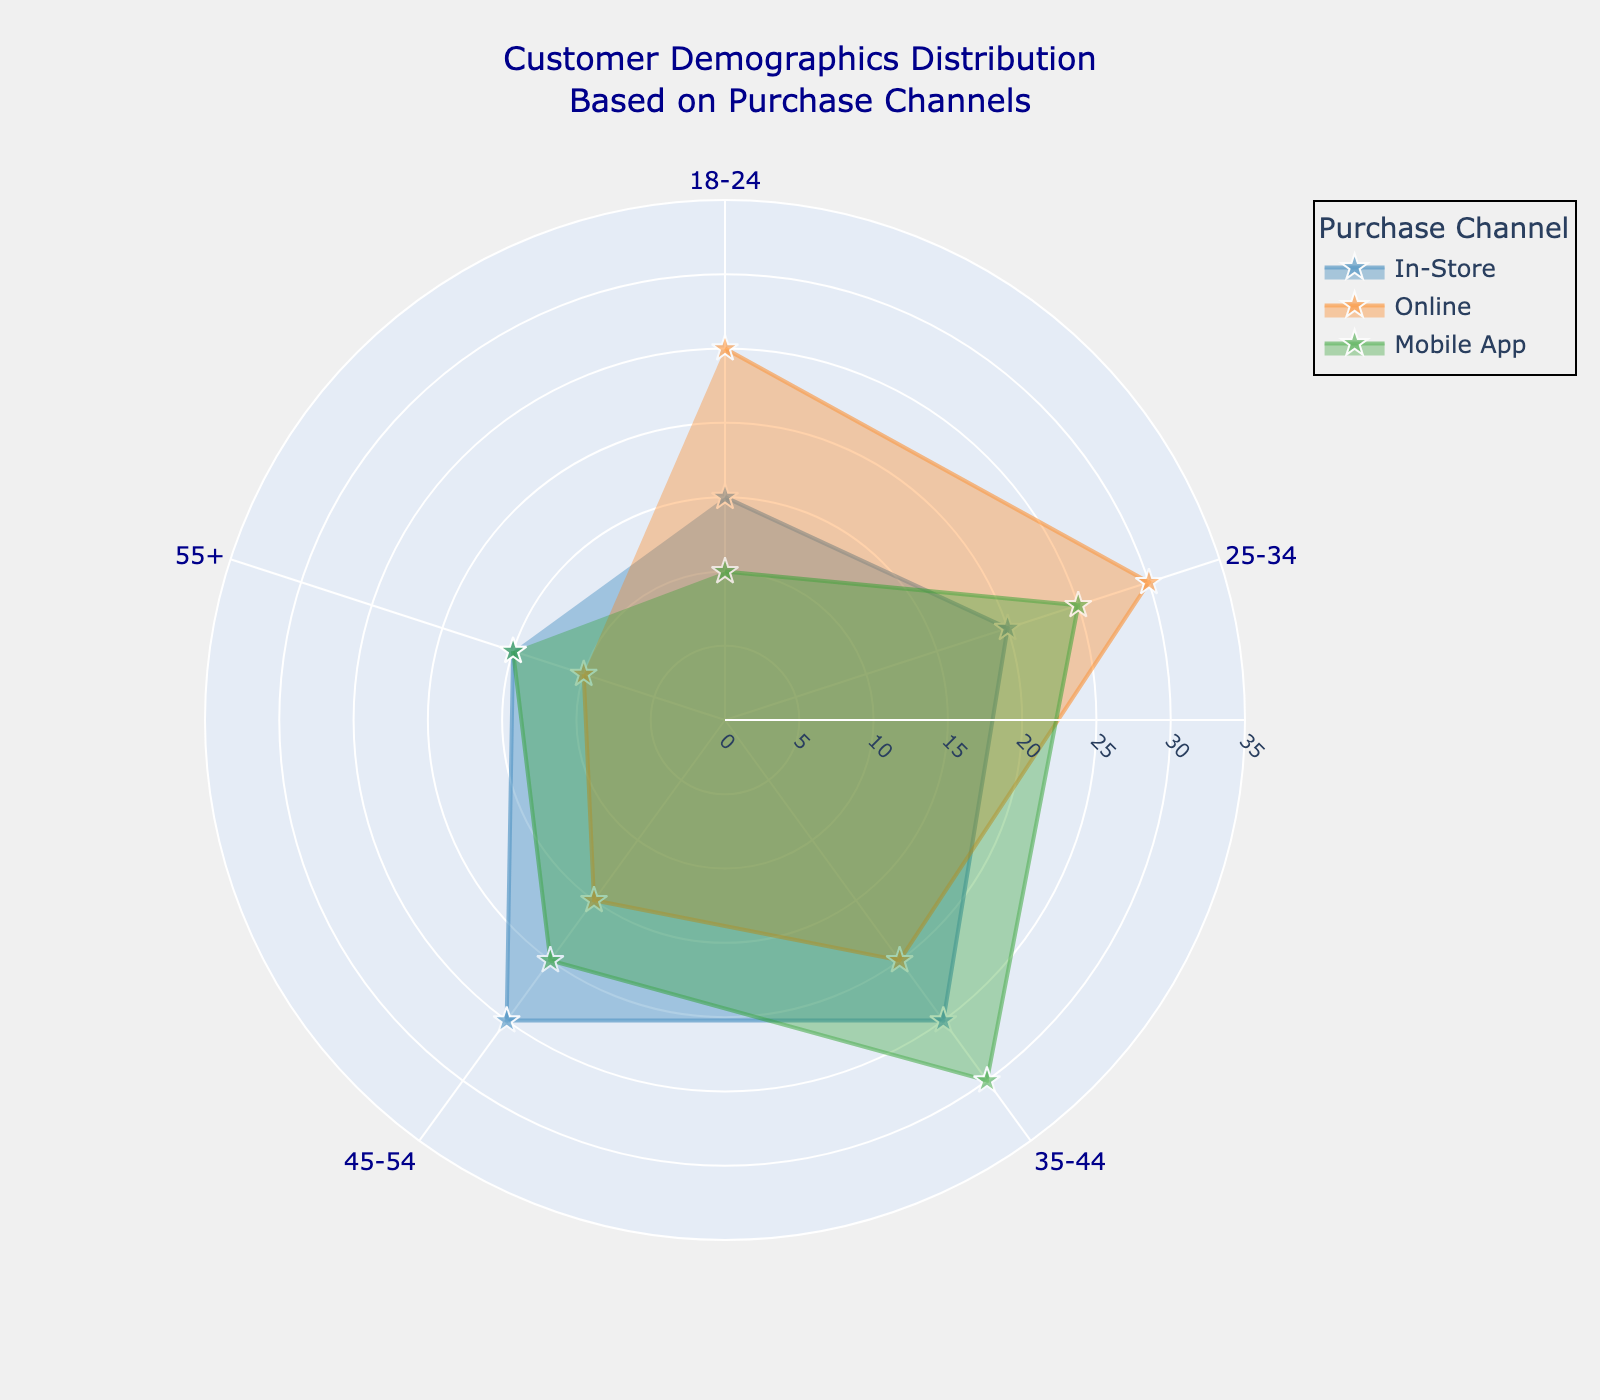What is the title of the chart? The title of the chart is shown at the top and reads "Customer Demographics Distribution Based on Purchase Channels."
Answer: Customer Demographics Distribution Based on Purchase Channels How many purchase channels are displayed in the chart? The legend on the chart indicates the purchase channels, which are In-Store, Online, and Mobile App.
Answer: 3 Which age group has the highest percentage for the Online purchase channel? By looking at the Online trace and comparing the percentages for each age group, the 25-34 age group has the highest percentage at 30%.
Answer: 25-34 In which purchase channel does the 35-44 age group have a higher percentage compared to the 25-34 age group? Comparing each purchase channel trace, in the Mobile App channel, the 35-44 age group's percentage (30%) is higher than the 25-34 age group's percentage (25%).
Answer: Mobile App What is the sum of the percentages for the 45-54 age group across all purchase channels? Adding up the percentages for the 45-54 age group: In-Store (25%) + Online (15%) + Mobile App (20%) = 60%.
Answer: 60% Which purchase channel shows the most balanced distribution among the age groups? By visually comparing the spans in the polar area chart, the In-Store channel shows more balanced percentages across age groups, varying from 15% to 25%.
Answer: In-Store Is there any age group where the percentage in the In-Store channel is equal to that in the Mobile App channel? For the 55+ age group, both In-Store and Mobile App channels have a percentage of 15%.
Answer: Yes Which age group has the largest difference in percentage between the Online and Mobile App channels? The 18-24 age group has a 15% difference between Online (25%) and Mobile App (10%) channels.
Answer: 18-24 What is the average percentage of the 18-24 age group across all purchase channels? The percentages for the 18-24 age group: In-Store (15%) + Online (25%) + Mobile App (10%). Sum is 50%, and the average is 50/3 ≈ 16.67%.
Answer: 16.67% How does the percentage for the 35-44 age group in the Mobile App channel compare to the Online channel for the same age group? The 35-44 age group has 30% in the Mobile App channel and 20% in the Online channel, making Mobile App 10% higher.
Answer: 10% higher 